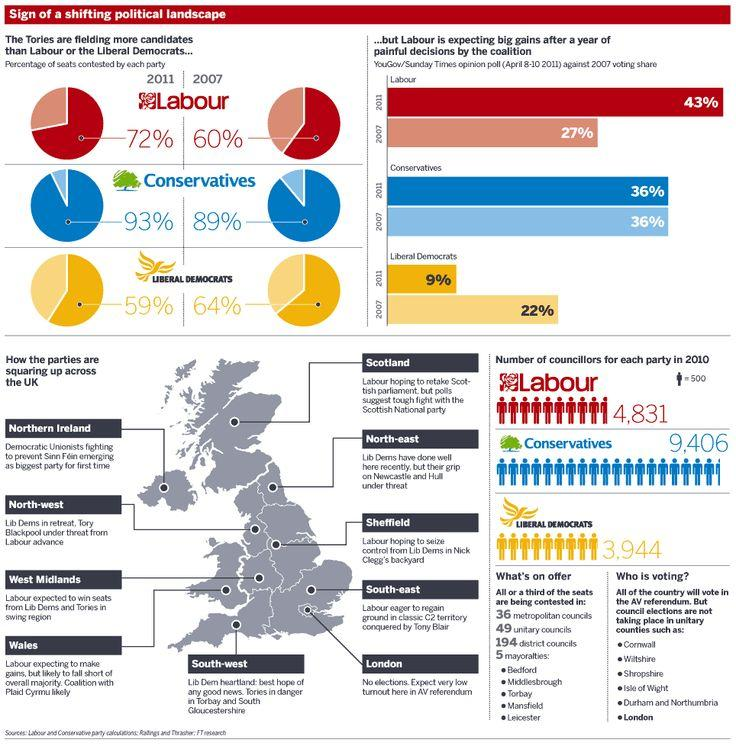Outline some significant characteristics in this image. In 2011, Labour saw an increase in voting share compared to 2007. The Liberal Democrats had fewer seats in 2011 compared to 2007. The Labour party anticipates a challenging battle against the Scottish National Party in Scotland. The Conservative party had the highest number of councillors in 2010. Elections will not be taking place in London. 